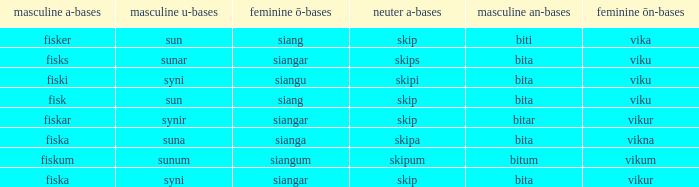What is the an-stem for the word which has an ö-stems of siangar and an u-stem ending of syni? Bita. 